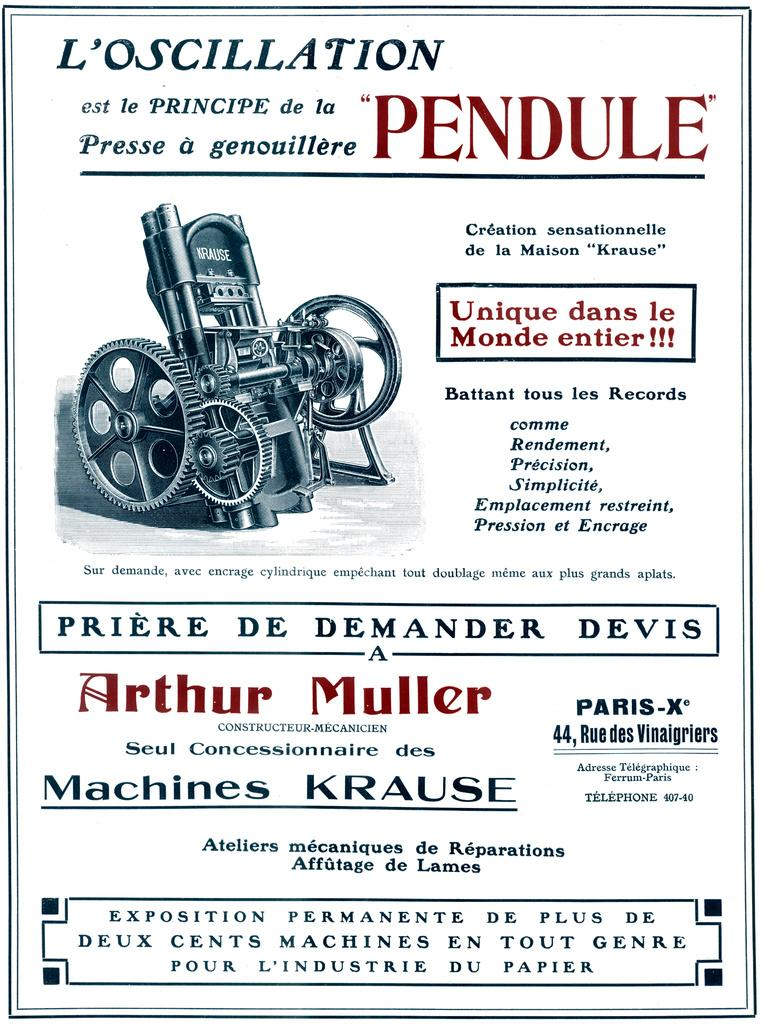What is featured on the poster in the image? There is a poster in the image, and it contains text and an image of a machine tool. What type of regret can be seen on the kitty's face in the image? There is no kitty present in the image, and therefore no such emotion can be observed. 